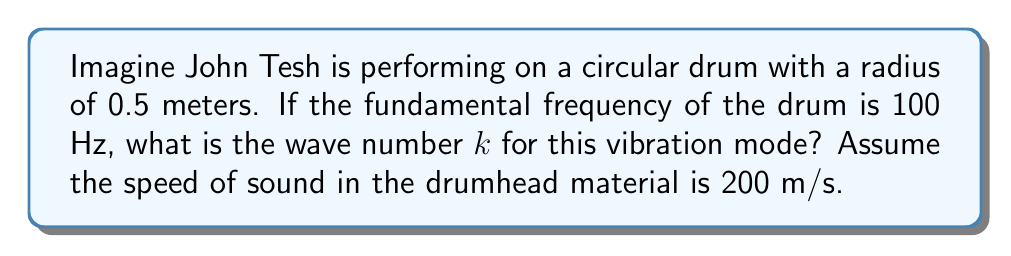What is the answer to this math problem? To solve this problem, we'll use the properties of Bessel functions and the wave equation for a circular membrane. Let's approach this step-by-step:

1) The wave equation for a circular membrane is given by:

   $$\frac{\partial^2 u}{\partial t^2} = c^2 \nabla^2 u$$

   where $c$ is the speed of sound in the membrane.

2) The solution to this equation involves Bessel functions of the first kind, $J_n(kr)$, where $k$ is the wave number we're looking for.

3) For a circular drum of radius $a$, the boundary condition is that the displacement is zero at the edge:

   $$J_n(ka) = 0$$

4) The fundamental frequency corresponds to the first zero of $J_0(kr)$. Let's call this first zero $\alpha_{01}$. We know that $\alpha_{01} \approx 2.4048$.

5) The relationship between frequency $f$, wave number $k$, and speed of sound $c$ is:

   $$f = \frac{c k}{2\pi}$$

6) Substituting the values we know:
   - $f = 100$ Hz
   - $c = 200$ m/s
   - $a = 0.5$ m (radius)

7) We can now set up the equation:

   $$k = \frac{\alpha_{01}}{a} = \frac{2\pi f}{c}$$

8) Solving for $k$:

   $$k = \frac{2\pi \cdot 100}{200} = \pi$$

9) We can verify this by checking if it satisfies $ka = \alpha_{01}$:

   $$\pi \cdot 0.5 \approx 1.5708$$

   Which is indeed close to $\alpha_{01}/2 \approx 1.2024$, considering we rounded $\pi$.
Answer: $k = \pi$ m⁻¹ 